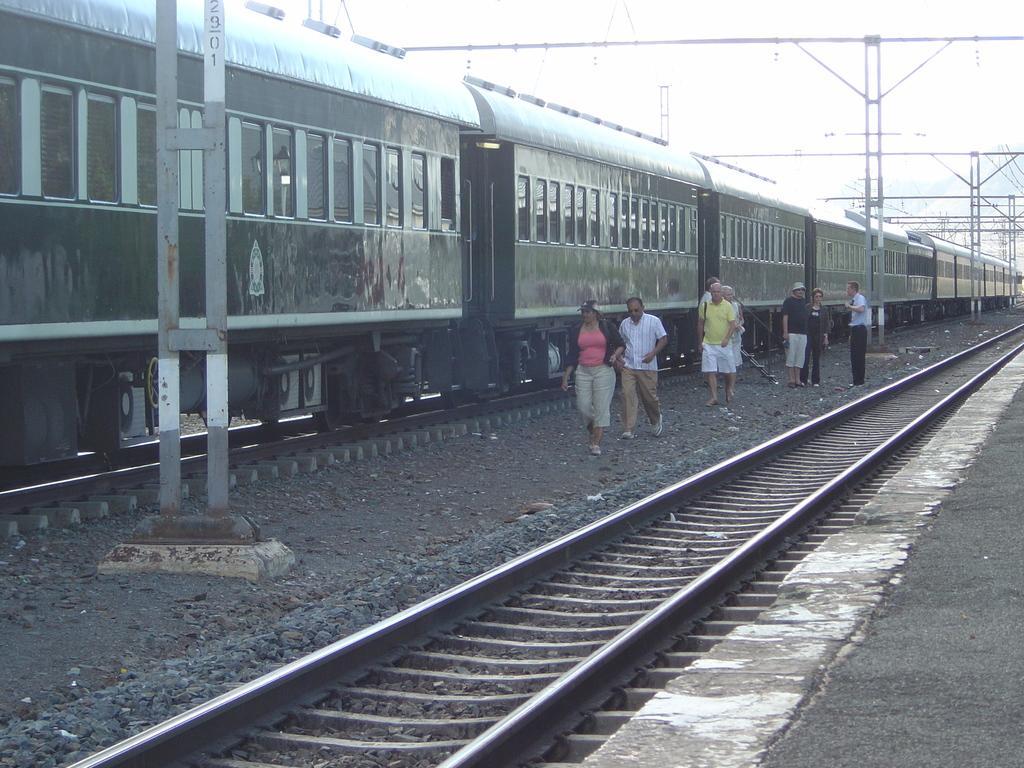Describe this image in one or two sentences. This is a train, which is on the rail track. I can see few people walking and few people standing. I think these are the current polls. This looks like an iron pillar. Here is the platform. These are the train coaches, which are connected to each other. 